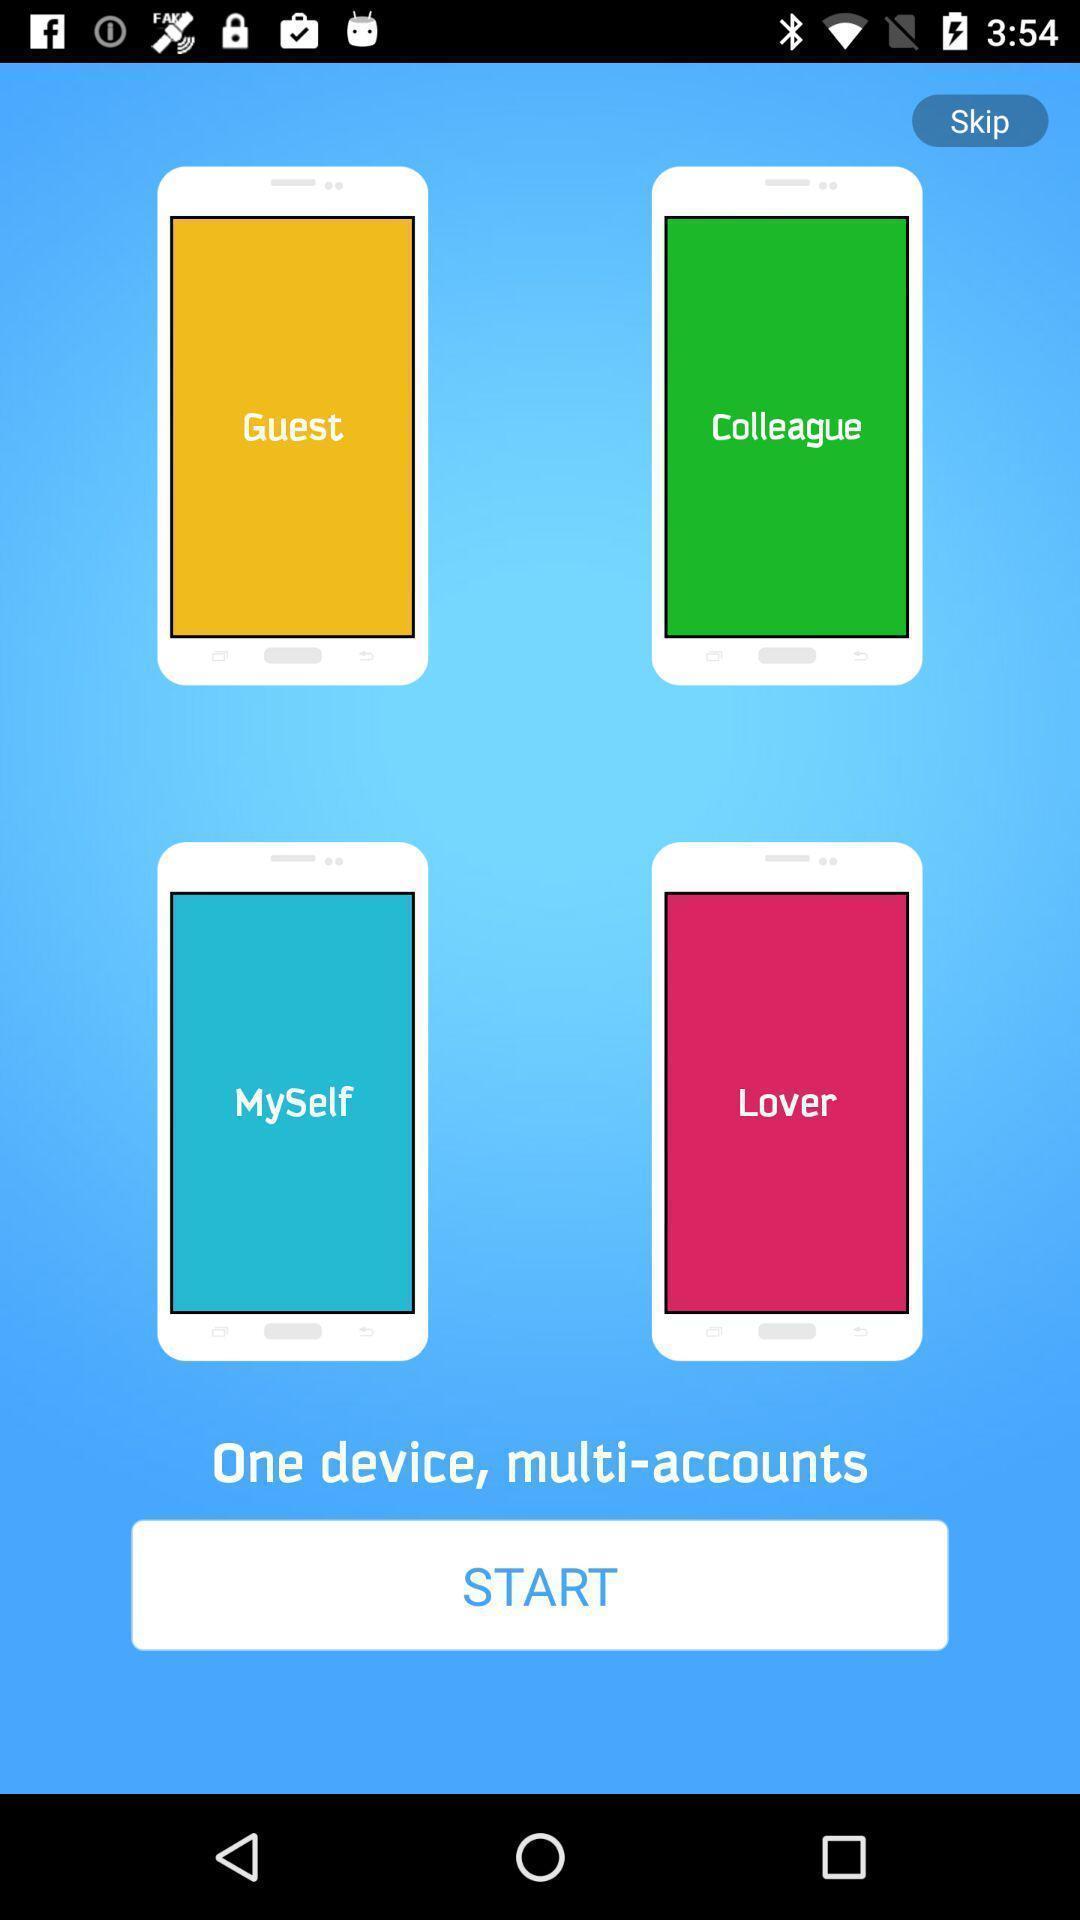Explain the elements present in this screenshot. Starting page of a multiple accounts application. 